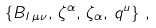Convert formula to latex. <formula><loc_0><loc_0><loc_500><loc_500>\left \{ B _ { I \, \mu \nu } , \, \zeta ^ { \alpha } , \, \zeta _ { \alpha } , \, q ^ { u } \right \} \, ,</formula> 